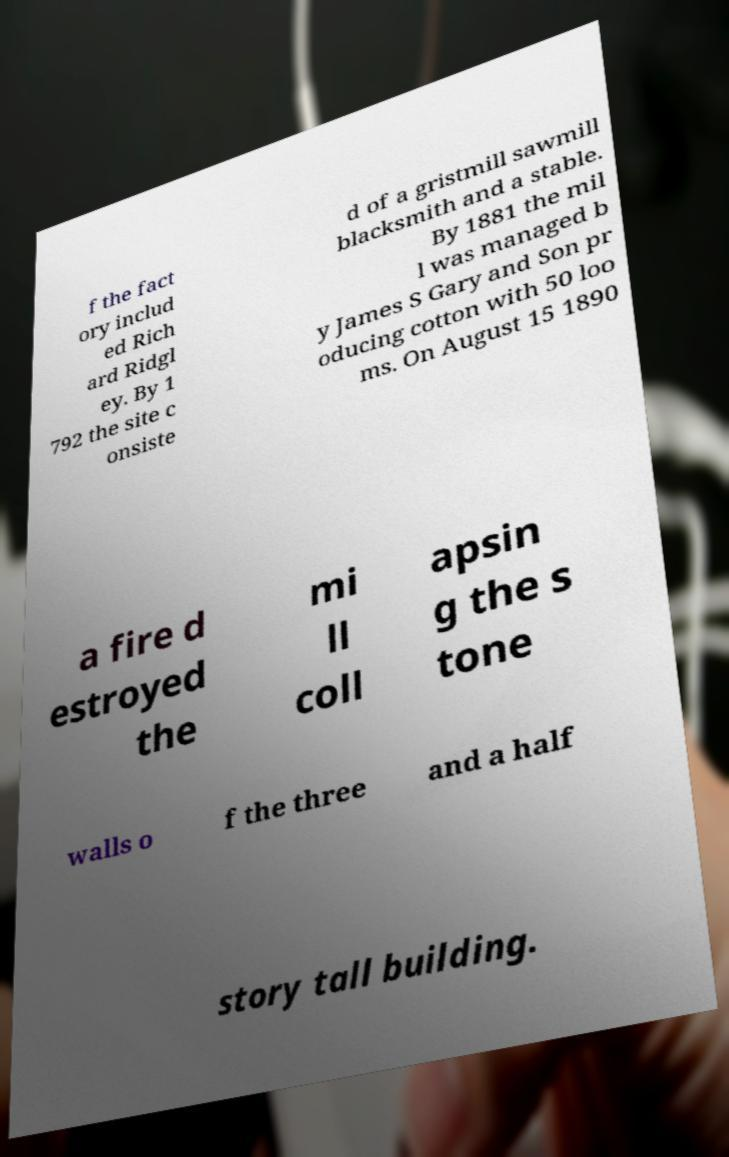For documentation purposes, I need the text within this image transcribed. Could you provide that? f the fact ory includ ed Rich ard Ridgl ey. By 1 792 the site c onsiste d of a gristmill sawmill blacksmith and a stable. By 1881 the mil l was managed b y James S Gary and Son pr oducing cotton with 50 loo ms. On August 15 1890 a fire d estroyed the mi ll coll apsin g the s tone walls o f the three and a half story tall building. 